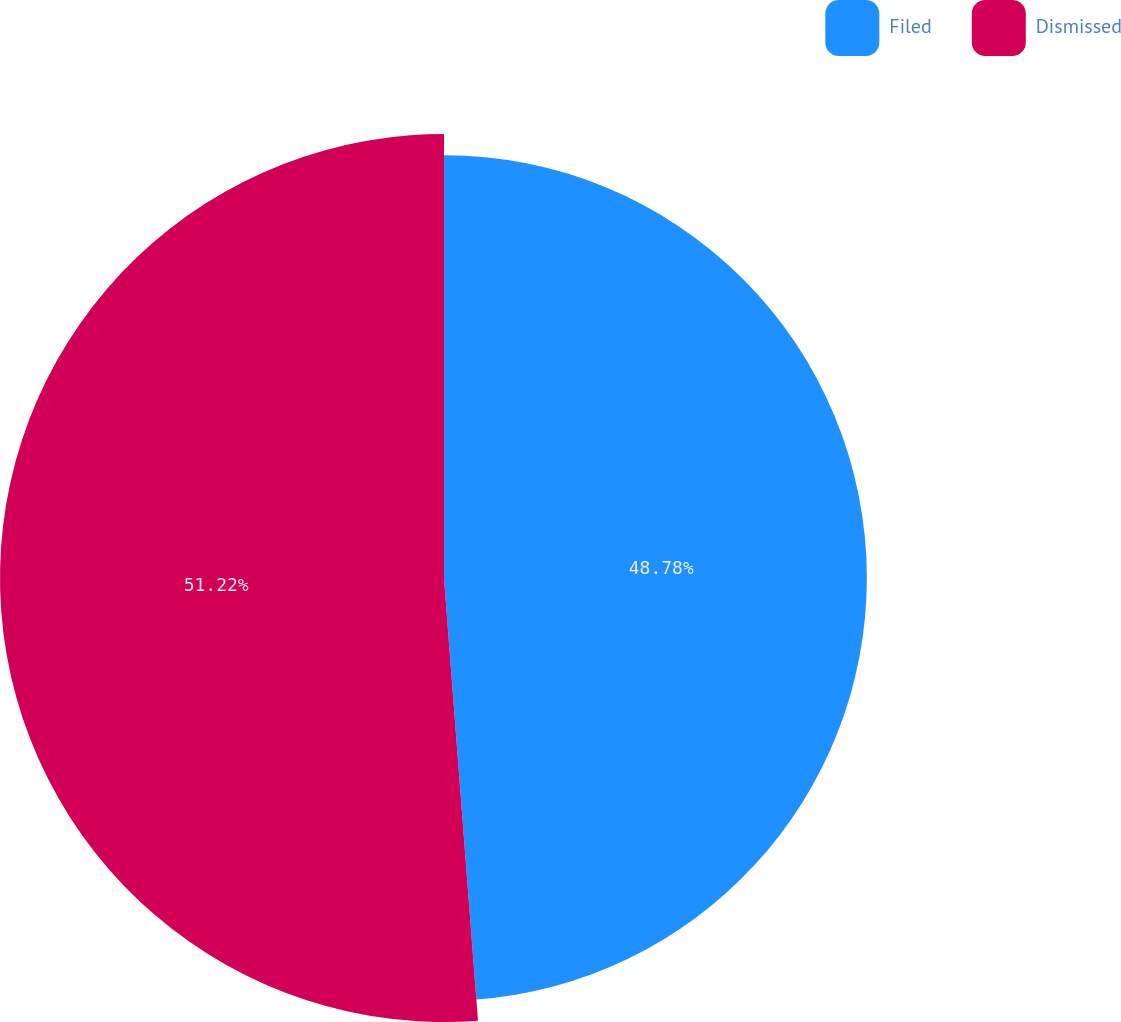Convert chart to OTSL. <chart><loc_0><loc_0><loc_500><loc_500><pie_chart><fcel>Filed<fcel>Dismissed<nl><fcel>48.78%<fcel>51.22%<nl></chart> 